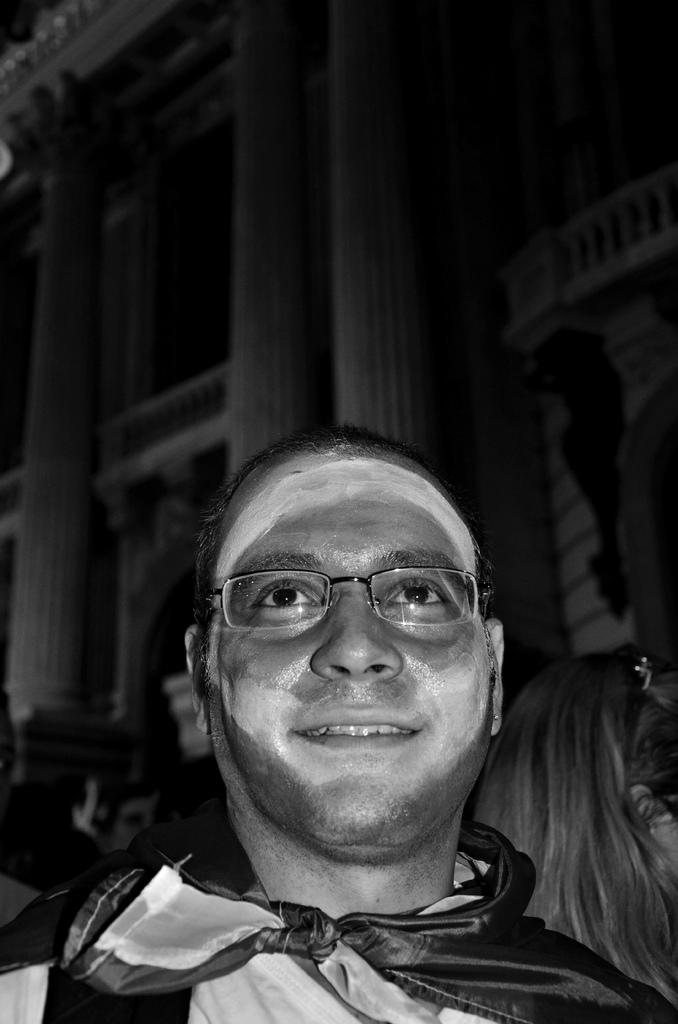What is the color scheme of the image? The image is black and white. Can you describe the main subject in the image? There is a person in the image. What can be seen in the background of the image? There is a building in the background of the image. What type of poison is being used by the person in the image? There is no indication of any poison or poisonous substance in the image; it only features a person and a building in the background. 